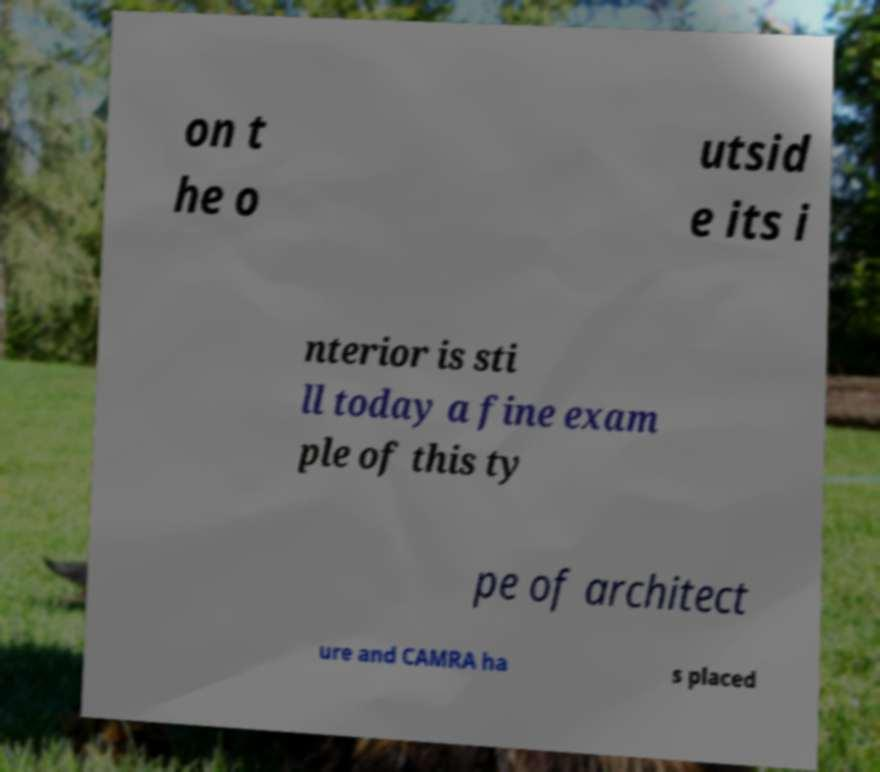Please identify and transcribe the text found in this image. on t he o utsid e its i nterior is sti ll today a fine exam ple of this ty pe of architect ure and CAMRA ha s placed 